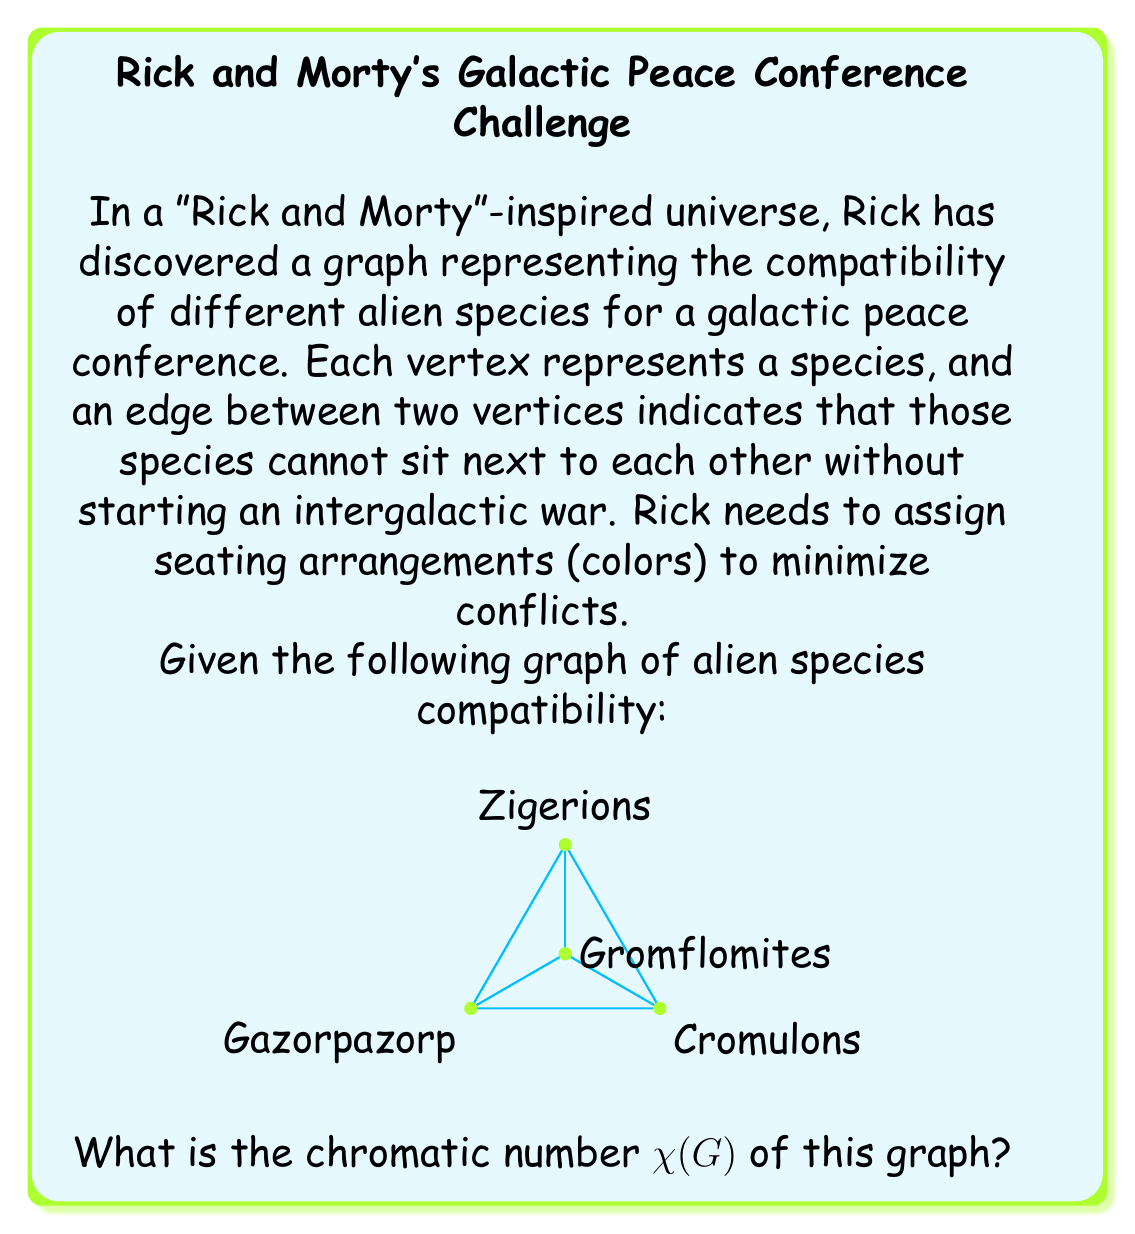What is the answer to this math problem? To find the chromatic number of this graph, we need to determine the minimum number of colors required to color all vertices such that no two adjacent vertices have the same color. Let's approach this step-by-step:

1) First, observe that the graph is a complete graph $K_4$ (all vertices are connected to each other), except for one missing edge between Gazorpazorp and Cromulons.

2) For a complete graph $K_n$, the chromatic number is always $n$, as each vertex needs a unique color. However, our graph is not quite complete.

3) Let's try to color the graph:
   - Start with Zigerions: Assign color 1.
   - Gromflomites: Adjacent to Zigerions, so assign color 2.
   - Gazorpazorp: Adjacent to both Zigerions and Gromflomites, so assign color 3.
   - Cromulons: Adjacent to Zigerions and Gromflomites, but not to Gazorpazorp. We can use color 3.

4) We've successfully colored the graph using 3 colors.

5) To prove that 2 colors are not sufficient:
   - The subgraph formed by Zigerions, Gromflomites, and Gazorpazorp is a triangle ($K_3$).
   - A triangle always requires 3 colors.

Therefore, the chromatic number $\chi(G) = 3$.

In "Rick and Morty" terms, Rick needs at least 3 different seating arrangements to keep all these alien species from starting an intergalactic war.
Answer: $\chi(G) = 3$ 